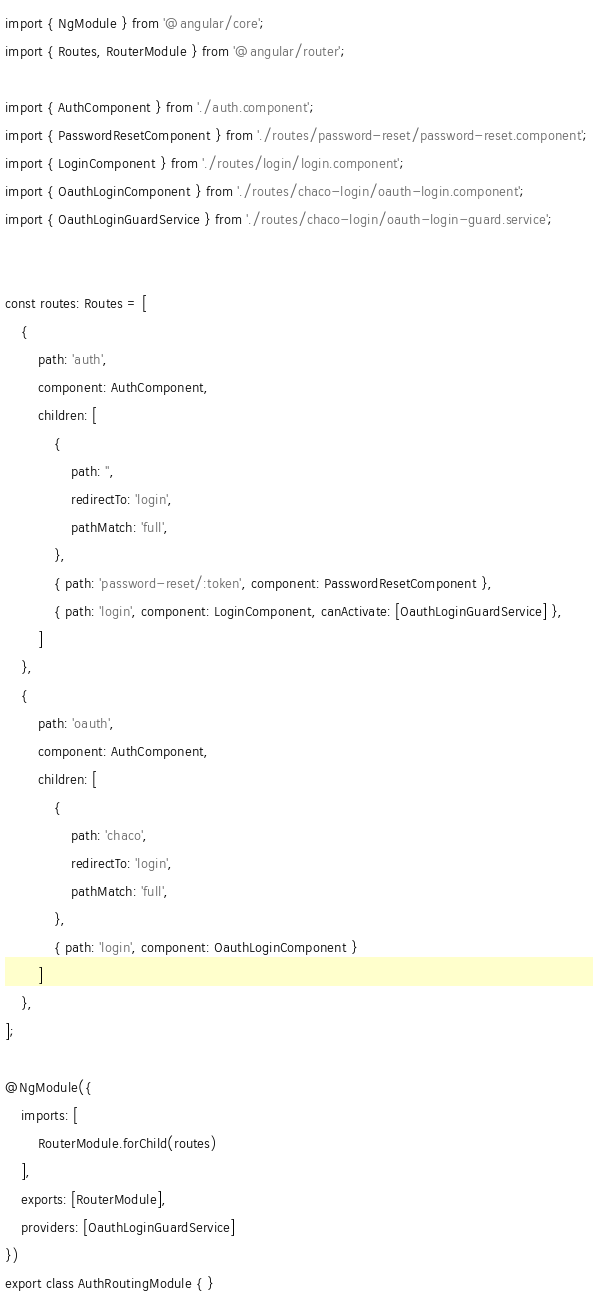<code> <loc_0><loc_0><loc_500><loc_500><_TypeScript_>import { NgModule } from '@angular/core';
import { Routes, RouterModule } from '@angular/router';

import { AuthComponent } from './auth.component';
import { PasswordResetComponent } from './routes/password-reset/password-reset.component';
import { LoginComponent } from './routes/login/login.component';
import { OauthLoginComponent } from './routes/chaco-login/oauth-login.component';
import { OauthLoginGuardService } from './routes/chaco-login/oauth-login-guard.service';


const routes: Routes = [
	{
		path: 'auth',
		component: AuthComponent,
		children: [
			{
				path: '',
				redirectTo: 'login',
				pathMatch: 'full',
			},
			{ path: 'password-reset/:token', component: PasswordResetComponent },
			{ path: 'login', component: LoginComponent, canActivate: [OauthLoginGuardService] },
		]
	},
	{
		path: 'oauth',
		component: AuthComponent,
		children: [
			{
				path: 'chaco',
				redirectTo: 'login',
				pathMatch: 'full',
			},
			{ path: 'login', component: OauthLoginComponent }
		]
	},
];

@NgModule({
	imports: [
		RouterModule.forChild(routes)
	],
	exports: [RouterModule],
	providers: [OauthLoginGuardService]
})
export class AuthRoutingModule { }
</code> 